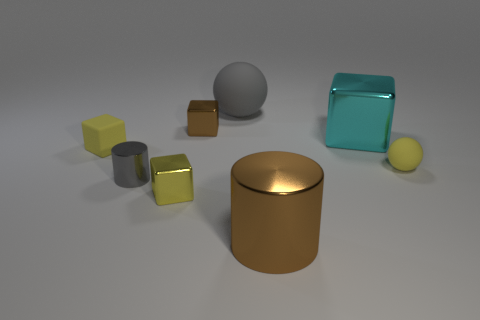Subtract all yellow rubber blocks. How many blocks are left? 3 Subtract all gray cylinders. How many cylinders are left? 1 Add 2 large purple matte cylinders. How many objects exist? 10 Subtract all balls. How many objects are left? 6 Subtract all cyan cylinders. How many yellow cubes are left? 2 Subtract all blue cylinders. Subtract all yellow spheres. How many cylinders are left? 2 Subtract all cyan metal things. Subtract all small yellow matte things. How many objects are left? 5 Add 8 small brown cubes. How many small brown cubes are left? 9 Add 7 tiny brown cubes. How many tiny brown cubes exist? 8 Subtract 0 green spheres. How many objects are left? 8 